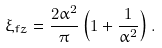Convert formula to latex. <formula><loc_0><loc_0><loc_500><loc_500>\xi _ { f z } = \frac { 2 \alpha ^ { 2 } } { \pi } \left ( 1 + \frac { 1 } { \alpha ^ { 2 } } \right ) .</formula> 